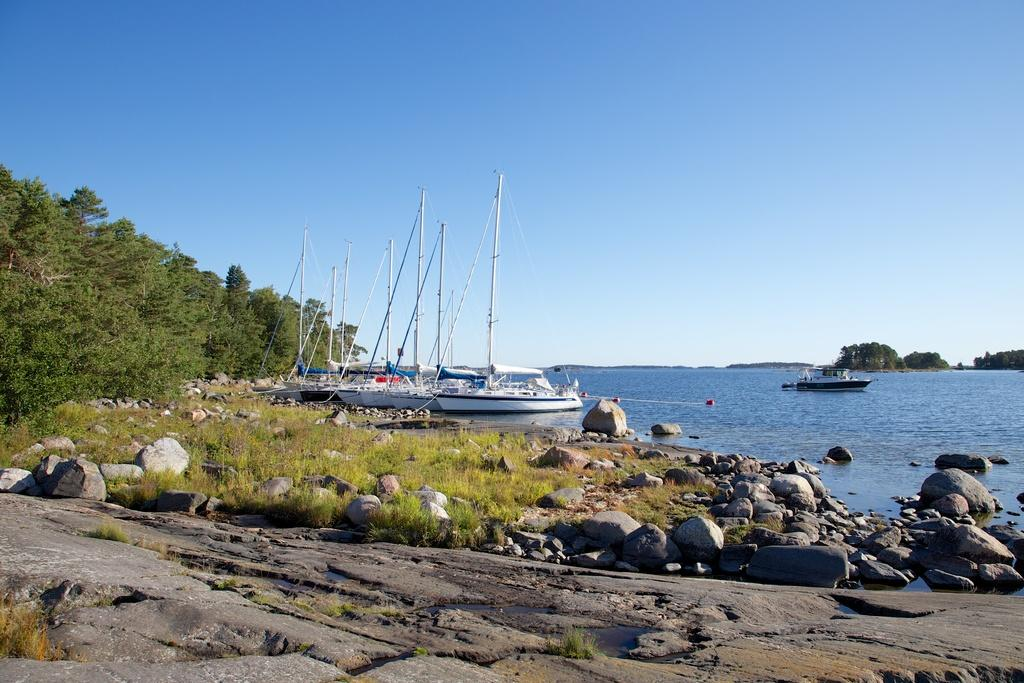What type of vehicles can be seen on the water in the image? There are boats on the water in the image. What is visible at the bottom of the image? Stones are visible at the bottom of the image. What type of vegetation is present in the image? Grass is present in the image. What other natural elements can be seen in the image? There are trees in the image. What is the condition of the sky in the background of the image? The sky is clear in the background of the image. What type of wool can be seen on the trees in the image? There is no wool present on the trees in the image; they are covered with leaves. How does the anger of the boats affect the water in the image? There is no indication of anger in the image, and the boats do not have emotions. 